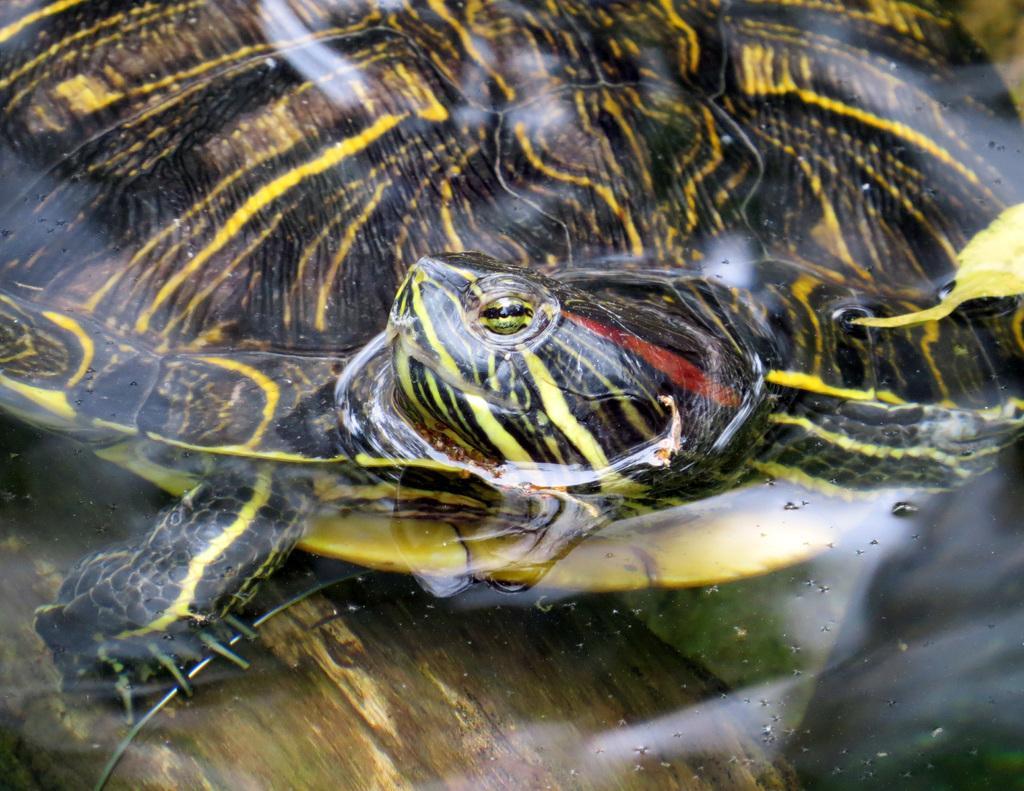In one or two sentences, can you explain what this image depicts? In this picture we can see a turtle like object. In the foreground we can see an object which seems to be the ground. 